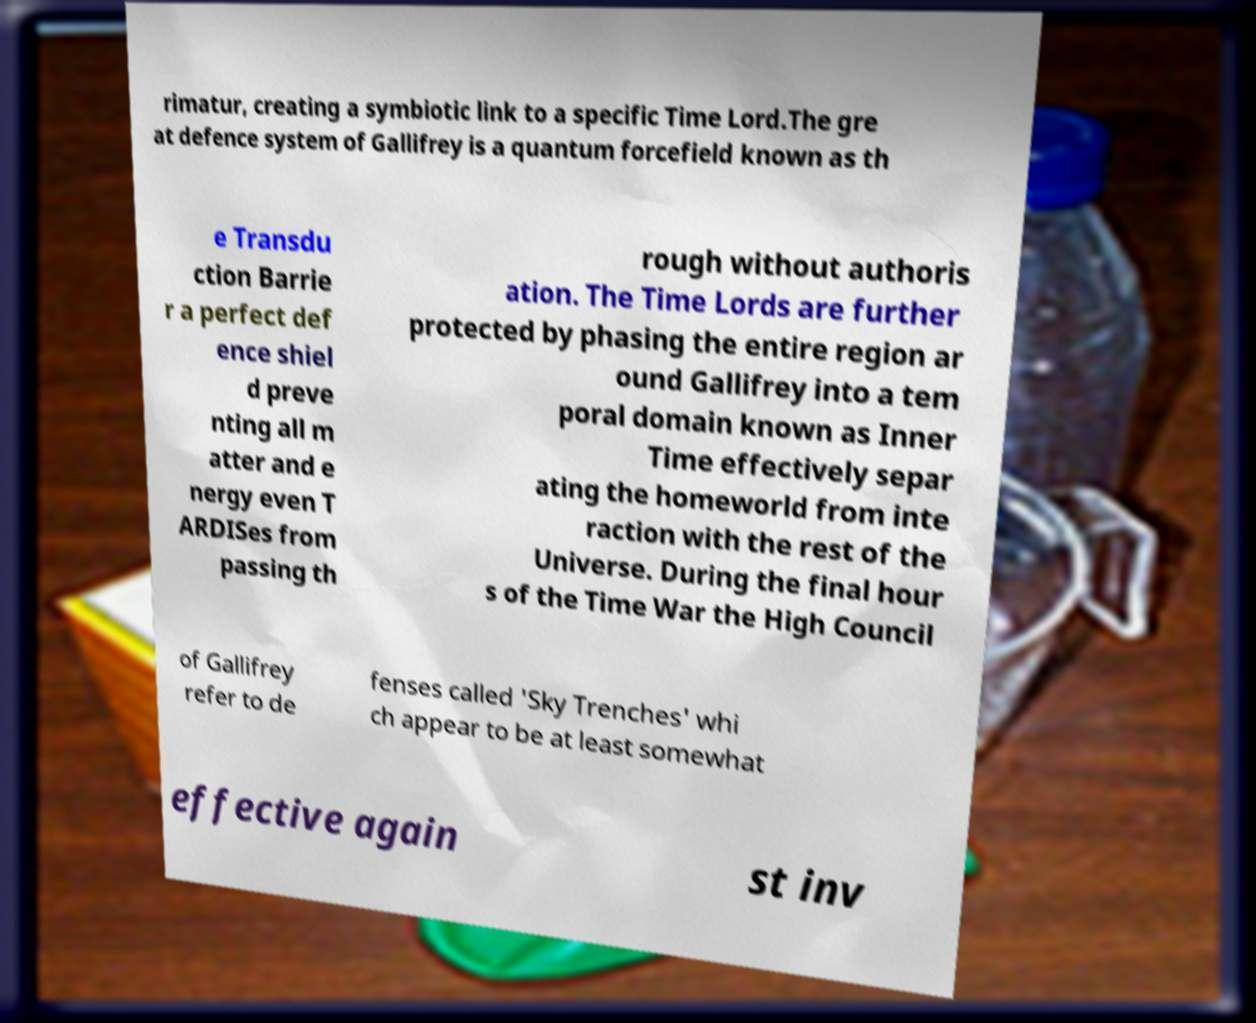Please read and relay the text visible in this image. What does it say? rimatur, creating a symbiotic link to a specific Time Lord.The gre at defence system of Gallifrey is a quantum forcefield known as th e Transdu ction Barrie r a perfect def ence shiel d preve nting all m atter and e nergy even T ARDISes from passing th rough without authoris ation. The Time Lords are further protected by phasing the entire region ar ound Gallifrey into a tem poral domain known as Inner Time effectively separ ating the homeworld from inte raction with the rest of the Universe. During the final hour s of the Time War the High Council of Gallifrey refer to de fenses called 'Sky Trenches' whi ch appear to be at least somewhat effective again st inv 